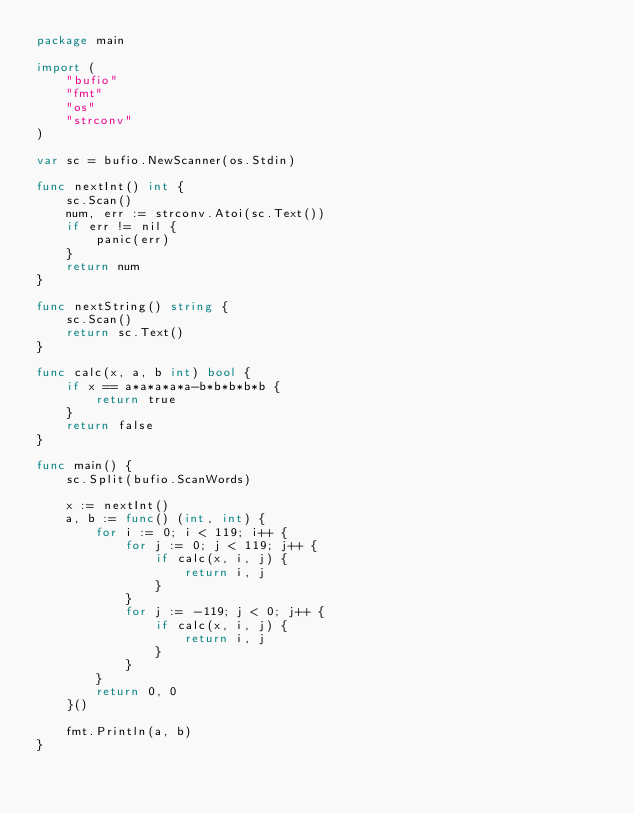<code> <loc_0><loc_0><loc_500><loc_500><_Go_>package main

import (
	"bufio"
	"fmt"
	"os"
	"strconv"
)

var sc = bufio.NewScanner(os.Stdin)

func nextInt() int {
	sc.Scan()
	num, err := strconv.Atoi(sc.Text())
	if err != nil {
		panic(err)
	}
	return num
}

func nextString() string {
	sc.Scan()
	return sc.Text()
}

func calc(x, a, b int) bool {
	if x == a*a*a*a*a-b*b*b*b*b {
		return true
	}
	return false
}

func main() {
	sc.Split(bufio.ScanWords)

	x := nextInt()
	a, b := func() (int, int) {
		for i := 0; i < 119; i++ {
			for j := 0; j < 119; j++ {
				if calc(x, i, j) {
					return i, j
				}
			}
			for j := -119; j < 0; j++ {
				if calc(x, i, j) {
					return i, j
				}
			}
		}
		return 0, 0
	}()

	fmt.Println(a, b)
}
</code> 